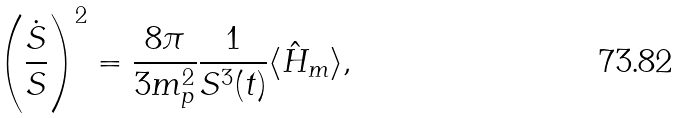Convert formula to latex. <formula><loc_0><loc_0><loc_500><loc_500>\left ( \frac { \dot { S } } { S } \right ) ^ { 2 } = \frac { 8 \pi } { 3 m ^ { 2 } _ { p } } \frac { 1 } { S ^ { 3 } ( t ) } \langle \hat { H } _ { m } \rangle ,</formula> 